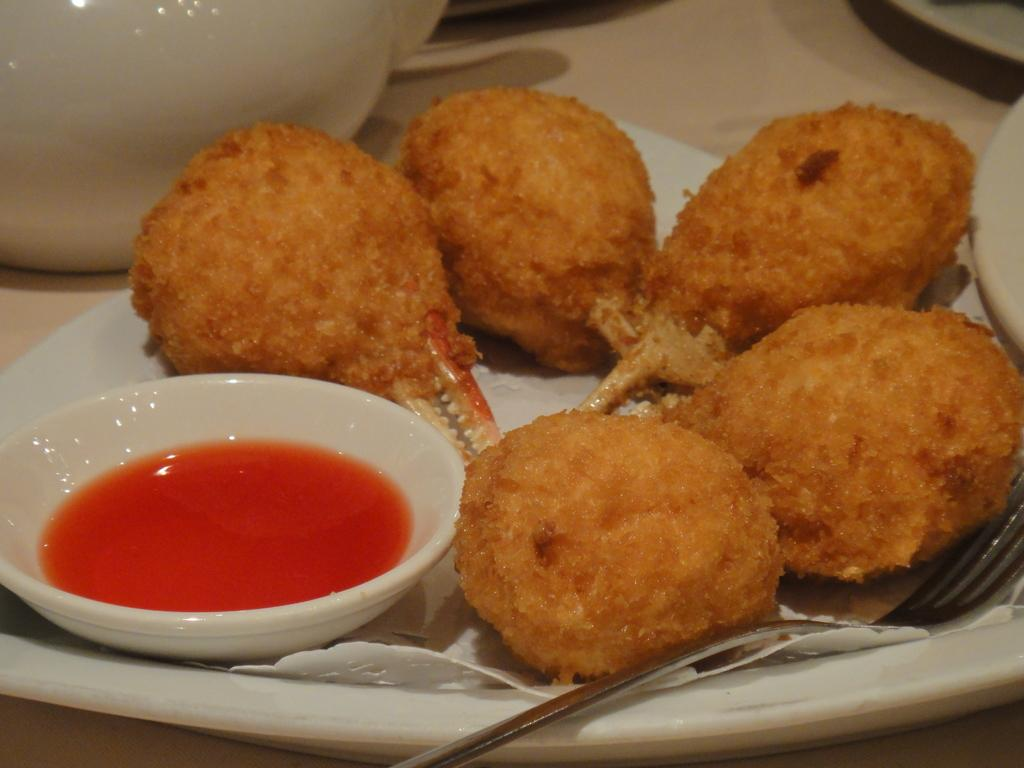What type of food items can be seen in the image? There are food items in the image, but their specific types are not mentioned. What is in the bowl that is visible in the image? There is a bowl with sauce in the image. What utensil is present in the image? There is a fork in the image. What color is the plate in the image? The plate is white in color. What other objects can be seen on the surface in the image? There are additional objects placed on the surface in the image, but their specific types are not mentioned. Are there any fairies visible in the image? No, there are no fairies present in the image. What is the condition of the dust in the image? There is no mention of dust in the image, so it cannot be determined if there is any dust or what its condition might be. 